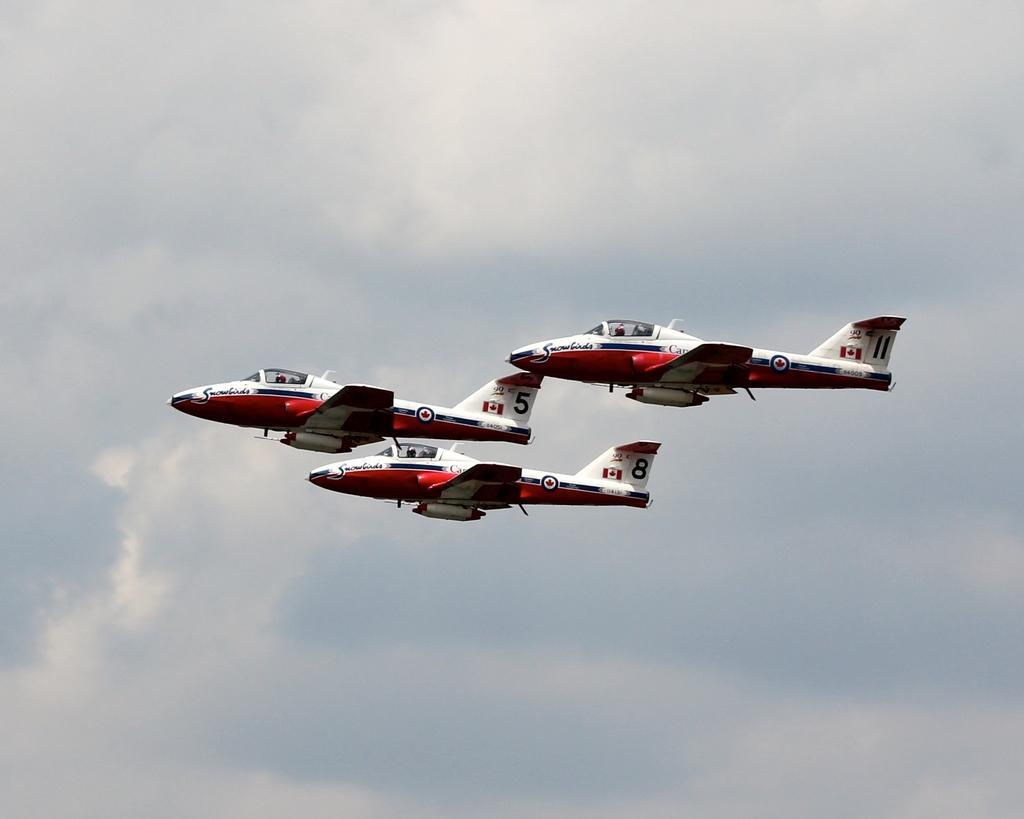In one or two sentences, can you explain what this image depicts? In this picture I can see three aircrafts flying in the sky. 